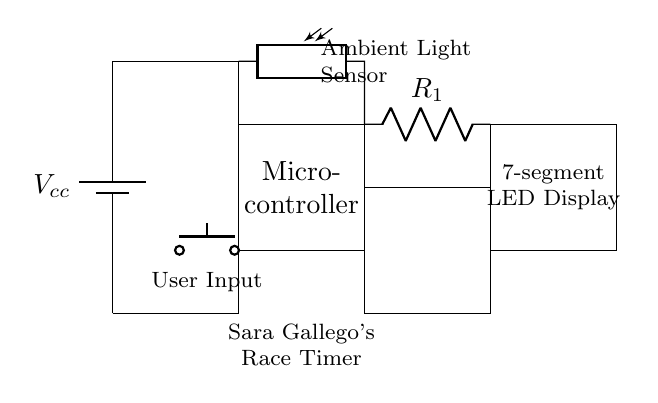What is the power supply in this circuit? The circuit uses a battery as the power supply, indicated by the symbol at the top left labeled as "Vcc."
Answer: Battery What component is used to sense ambient light? The circuit includes a photoresistor for sensing ambient light, shown connecting the power supply to the microcontroller and labeled accordingly.
Answer: Photoresistor How many main components are there in the circuit? There are three main components: the microcontroller, the LED display, and the photoresistor. All three are clearly depicted in the circuit diagram.
Answer: Three What is the purpose of the current limiting resistor? The current limiting resistor (labeled R1) is used to limit the current flowing to the LED display to prevent damage from excess current. It is shown in series with the LED display output.
Answer: Limit current What is the function of the button in the circuit? The push button serves as a user input device, allowing the user to interact with the microcontroller and potentially reset or start the timer. It is located below the microcontroller in the diagram.
Answer: User input If the LED display requires 2 volts, what is the voltage of the power supply? The power supply voltage, labeled as Vcc, is set at a higher voltage (considered common practice in circuits with microcontrollers), which usually is 5 volts in similar circuits. This accounts for the voltage needed by the microcontroller and other components.
Answer: Five volts Which component is likely responsible for displaying Sara Gallego's race times? The 7-segment LED display is responsible for displaying the race times, as indicated in the circuit with the rectangular block labeled as such.
Answer: 7-segment LED Display 